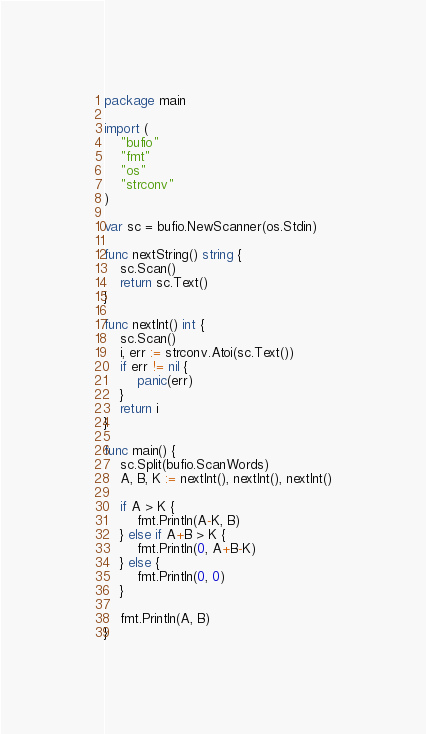<code> <loc_0><loc_0><loc_500><loc_500><_Go_>package main

import (
	"bufio"
	"fmt"
	"os"
	"strconv"
)

var sc = bufio.NewScanner(os.Stdin)

func nextString() string {
	sc.Scan()
	return sc.Text()
}

func nextInt() int {
	sc.Scan()
	i, err := strconv.Atoi(sc.Text())
	if err != nil {
		panic(err)
	}
	return i
}

func main() {
	sc.Split(bufio.ScanWords)
	A, B, K := nextInt(), nextInt(), nextInt()

	if A > K {
		fmt.Println(A-K, B)
	} else if A+B > K {
		fmt.Println(0, A+B-K)
	} else {
		fmt.Println(0, 0)
	}

	fmt.Println(A, B)
}
</code> 